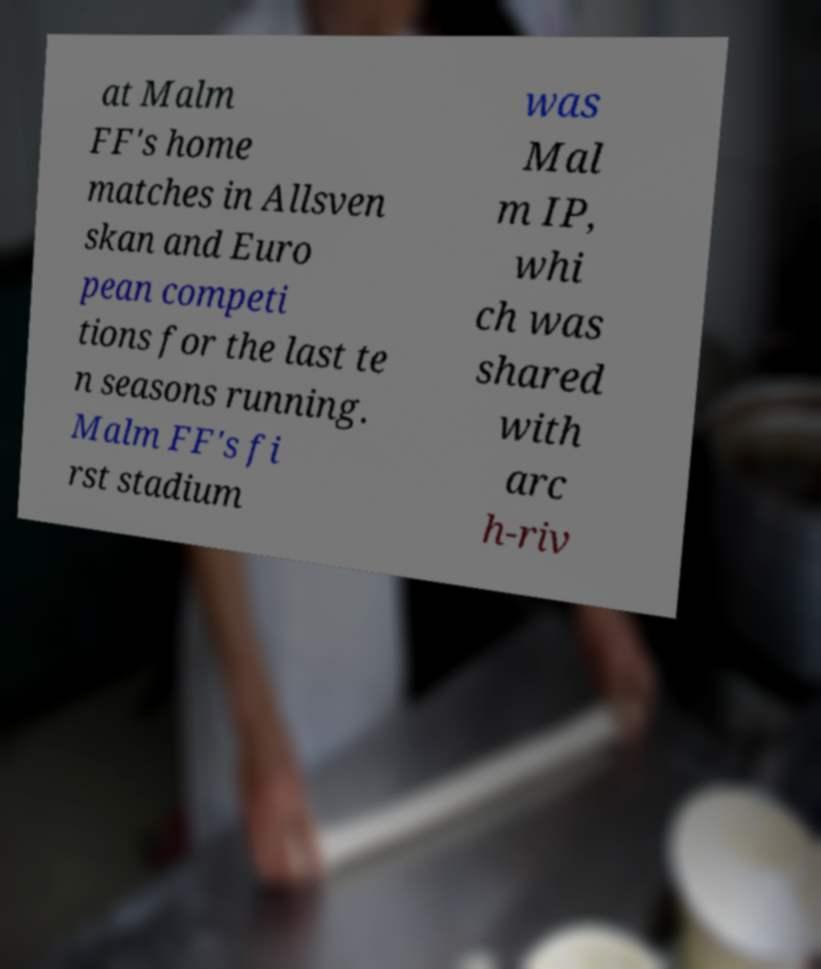Could you extract and type out the text from this image? at Malm FF's home matches in Allsven skan and Euro pean competi tions for the last te n seasons running. Malm FF's fi rst stadium was Mal m IP, whi ch was shared with arc h-riv 